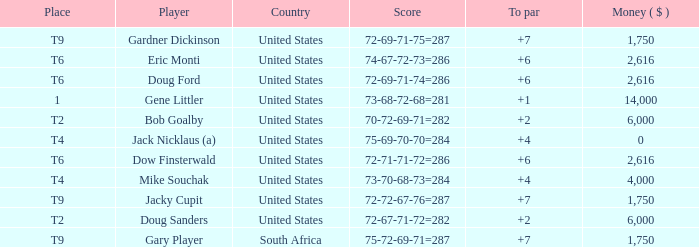What is the average To Par, when Score is "72-67-71-72=282"? 2.0. 